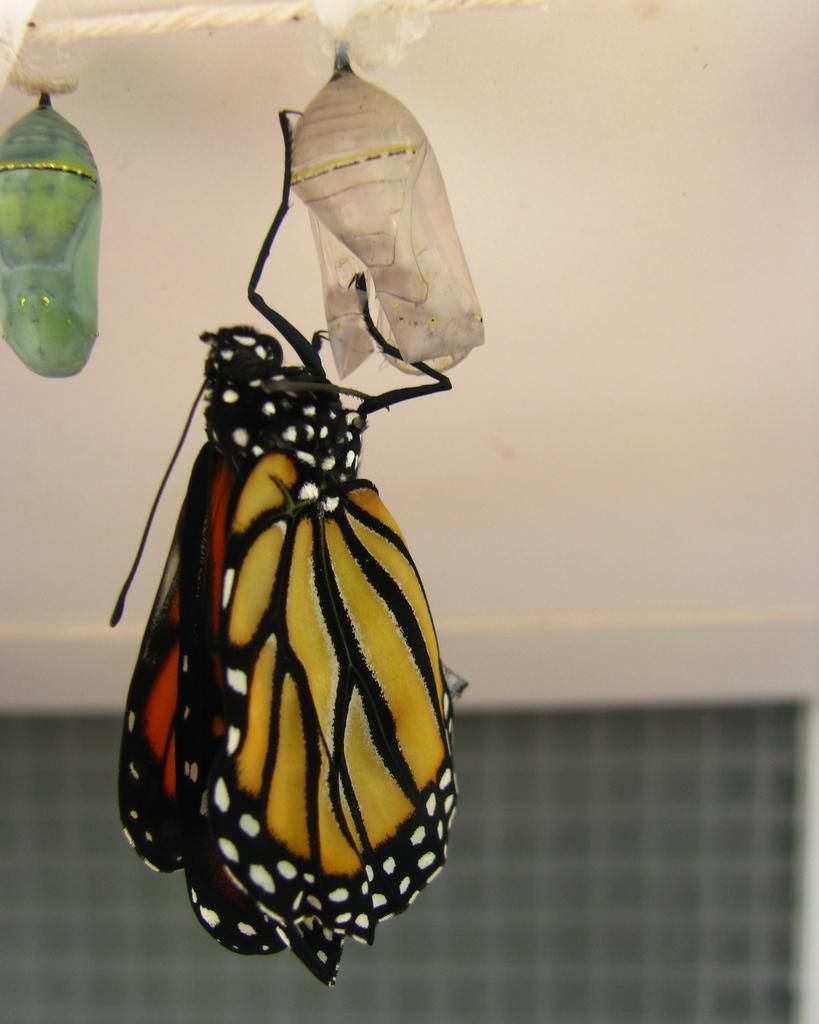What type of creature can be seen in the image? There is a butterfly in the image. What is the butterfly doing in the image? The butterfly is hanging onto an object. What can be seen in the background of the image? There is a wall in the background of the image. What architectural feature is present at the bottom of the image? There is a window at the bottom of the image. What type of mine can be seen in the image? There is no mine present in the image; it features a butterfly hanging onto an object. How many books are visible in the image? There are no books visible in the image. 